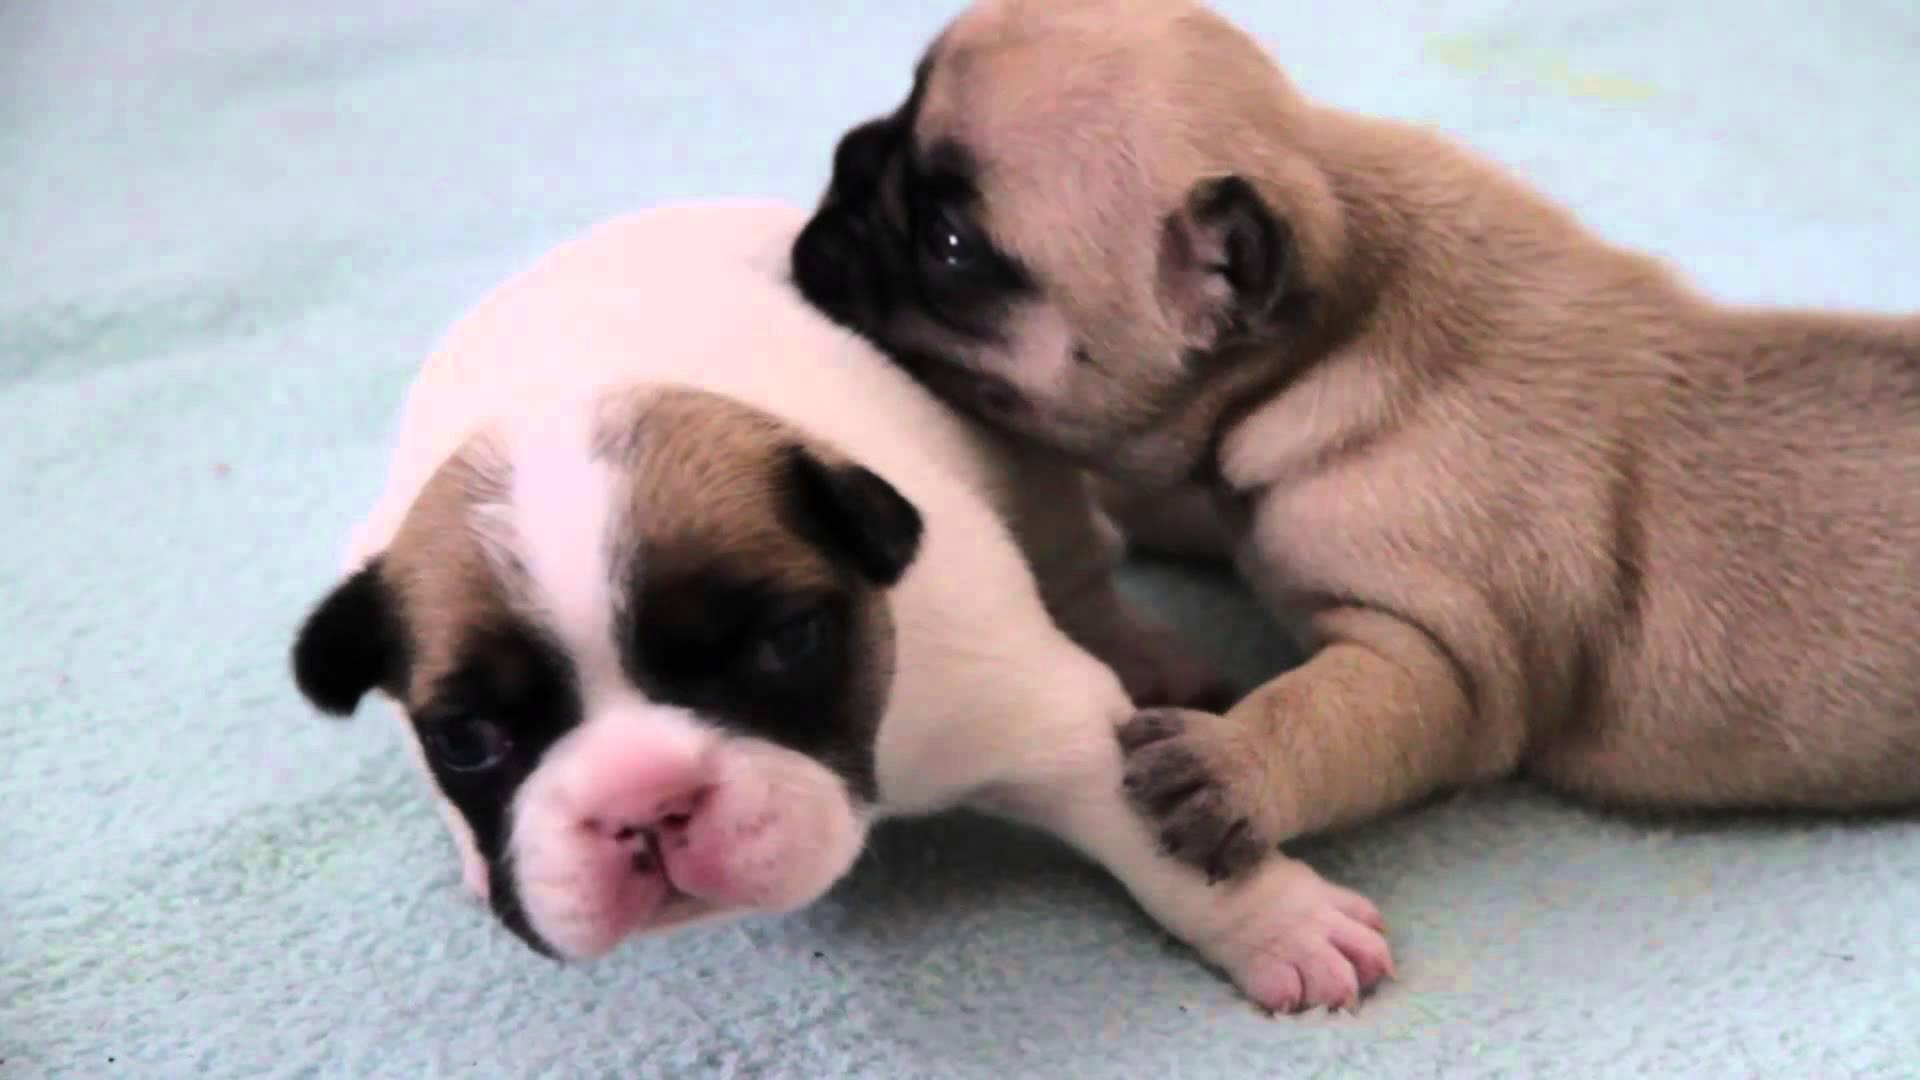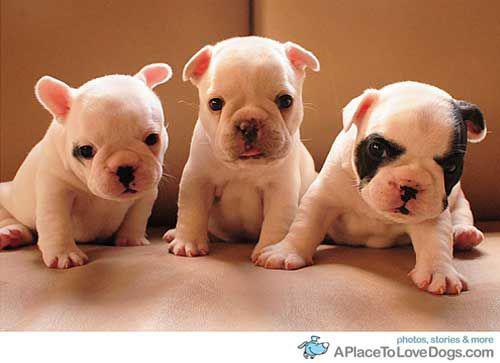The first image is the image on the left, the second image is the image on the right. Analyze the images presented: Is the assertion "A human is at least partially visible in the image on the right." valid? Answer yes or no. No. 